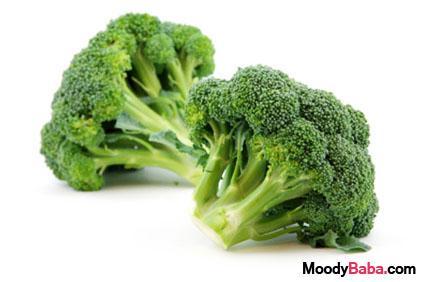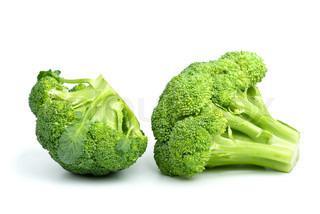The first image is the image on the left, the second image is the image on the right. For the images shown, is this caption "There are no more than four broccoli pieces" true? Answer yes or no. Yes. 